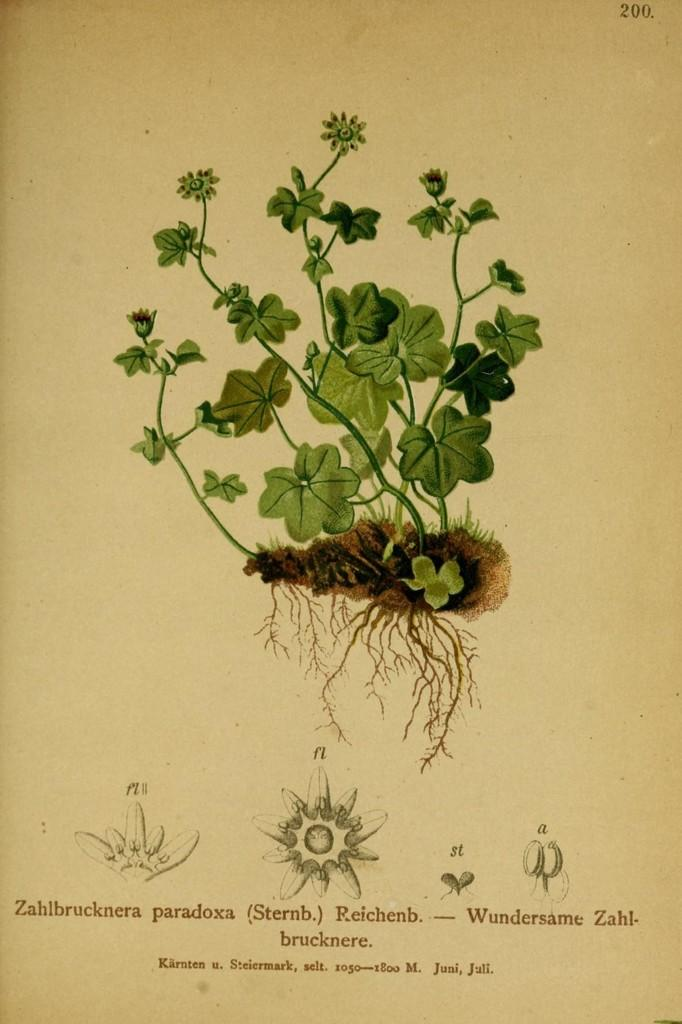What is depicted on the paper in the image? There is a picture of a plant and roots on the paper. What else can be seen on the paper besides the picture? There is writing on the paper. Are there any additional illustrations on the paper? Yes, there are drawings at the bottom of the image. Can you tell me how many pipes are visible in the image? There are no pipes present in the image; it features a picture of a plant and roots, writing, and drawings. What type of self-portrait can be seen in the image? There is no self-portrait present in the image. 